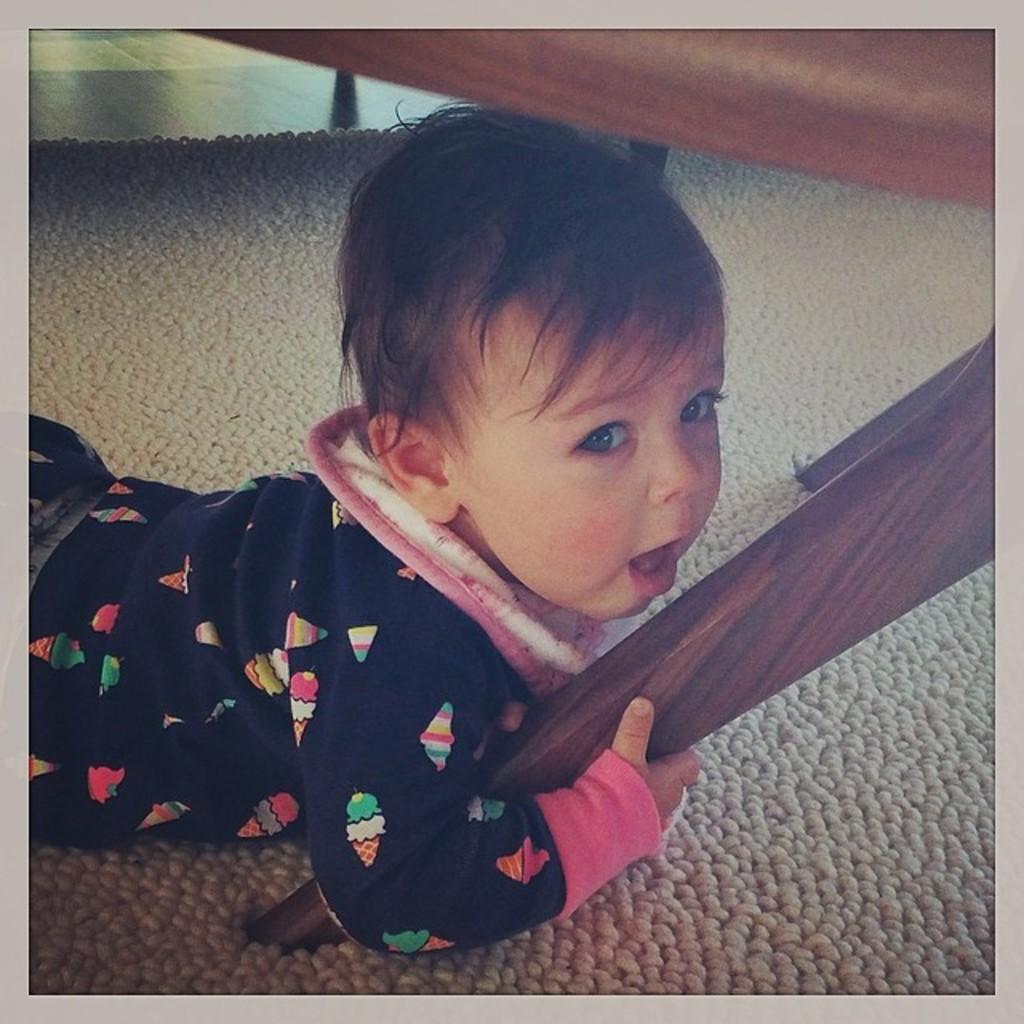In one or two sentences, can you explain what this image depicts? In this image I can see a baby is lying and holding a brown color object. I can see a floor mat. 